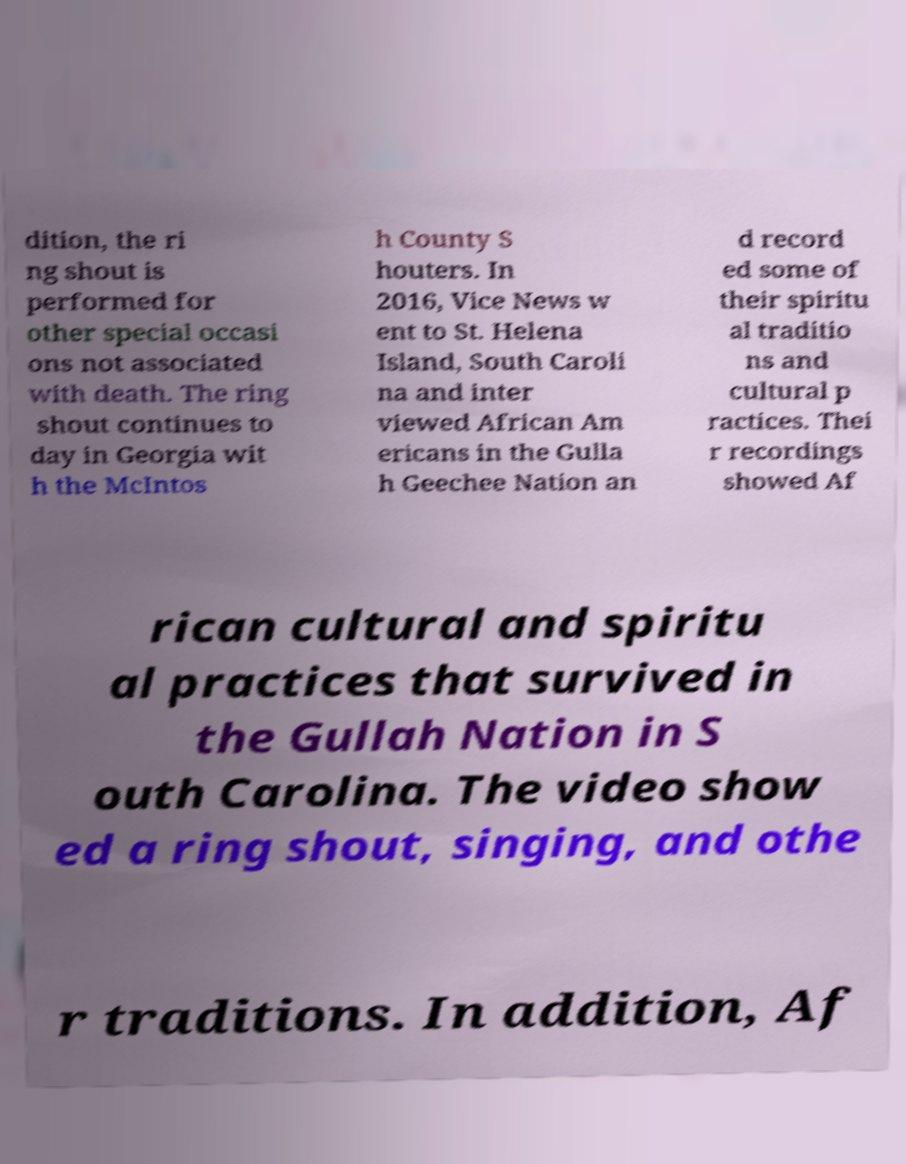Can you accurately transcribe the text from the provided image for me? dition, the ri ng shout is performed for other special occasi ons not associated with death. The ring shout continues to day in Georgia wit h the McIntos h County S houters. In 2016, Vice News w ent to St. Helena Island, South Caroli na and inter viewed African Am ericans in the Gulla h Geechee Nation an d record ed some of their spiritu al traditio ns and cultural p ractices. Thei r recordings showed Af rican cultural and spiritu al practices that survived in the Gullah Nation in S outh Carolina. The video show ed a ring shout, singing, and othe r traditions. In addition, Af 